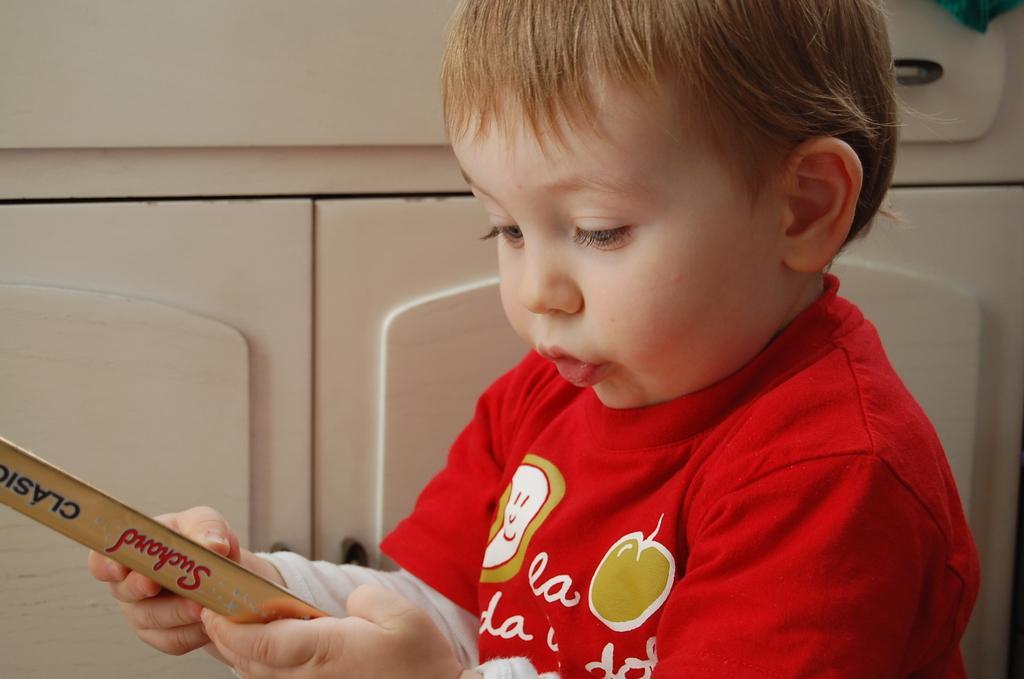Can you describe this image briefly? In this image we can see a kid holding an object. 